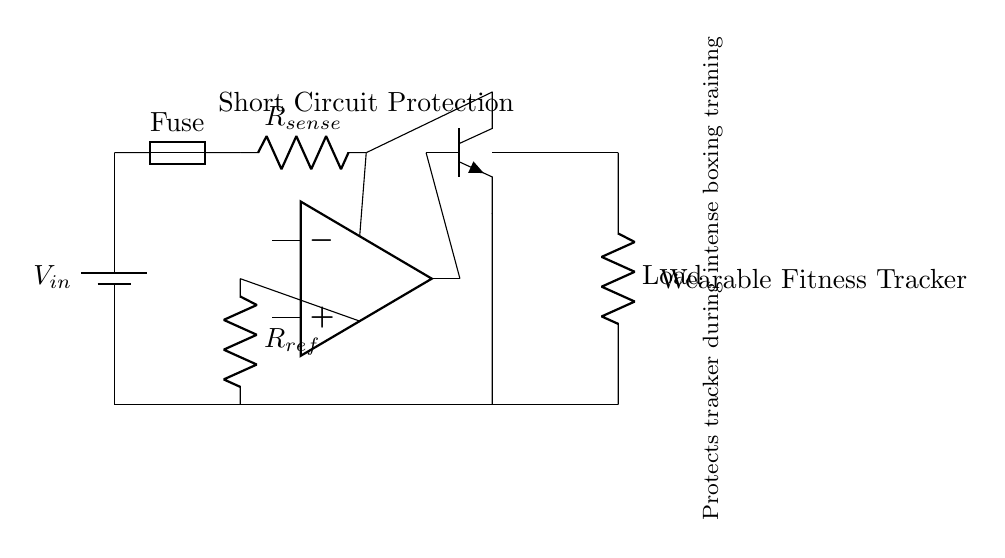What type of protection does this circuit provide? This circuit provides short circuit protection, which is indicated in the label at the top of the circuit diagram.
Answer: short circuit protection What is the purpose of the fuse in this circuit? The fuse is designed to break the circuit in the event of excessive current flow, acting as a safety device to prevent damage to the wearable fitness tracker.
Answer: safety device What component is used to sense current in this circuit? The current sense resistor, labeled as R sense, is responsible for sensing the current flow through the circuit.
Answer: R sense How many resistors are present in the circuit? There are two resistors: one is R sense for current sensing, and the second is R ref, used for reference voltage in the comparator.
Answer: two What happens when a short circuit occurs in this circuit? When a short circuit occurs, the current increases significantly, causing the fuse to blow and disconnecting the power from the load, protecting the wearable device.
Answer: power disconnects Which component controls the interruption of current flow during a short circuit? The transistor, which is connected to the output of the comparator, acts as a switch to control the interruption of current flow when a short circuit is detected.
Answer: transistor 